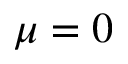<formula> <loc_0><loc_0><loc_500><loc_500>\mu = 0</formula> 